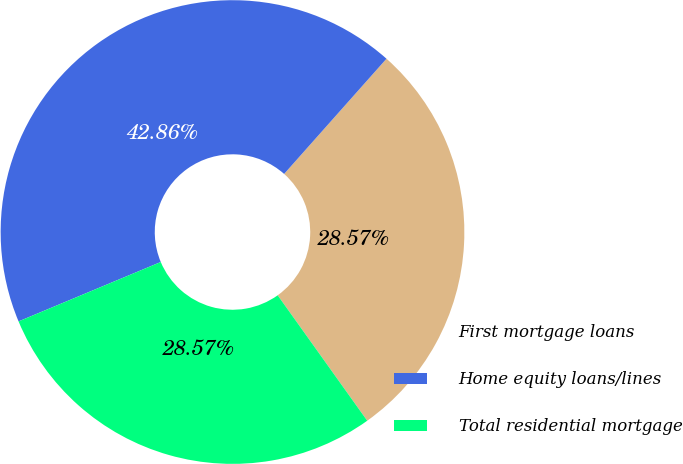Convert chart to OTSL. <chart><loc_0><loc_0><loc_500><loc_500><pie_chart><fcel>First mortgage loans<fcel>Home equity loans/lines<fcel>Total residential mortgage<nl><fcel>28.57%<fcel>42.86%<fcel>28.57%<nl></chart> 